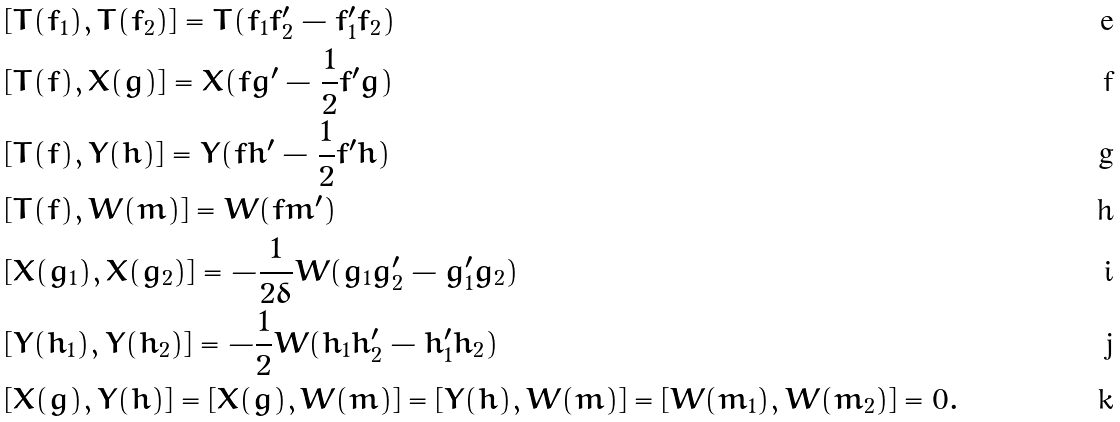<formula> <loc_0><loc_0><loc_500><loc_500>& [ T ( f _ { 1 } ) , T ( f _ { 2 } ) ] = T ( f _ { 1 } f ^ { \prime } _ { 2 } - f ^ { \prime } _ { 1 } f _ { 2 } ) \\ & [ T ( f ) , X ( g ) ] = X ( f g ^ { \prime } - \frac { 1 } { 2 } f ^ { \prime } g ) \\ & [ T ( f ) , Y ( h ) ] = Y ( f h ^ { \prime } - \frac { 1 } { 2 } f ^ { \prime } h ) \\ & [ T ( f ) , W ( m ) ] = W ( f m ^ { \prime } ) \\ & [ X ( g _ { 1 } ) , X ( g _ { 2 } ) ] = - \frac { 1 } { 2 \delta } W ( g _ { 1 } g ^ { \prime } _ { 2 } - g ^ { \prime } _ { 1 } g _ { 2 } ) \\ & [ Y ( h _ { 1 } ) , Y ( h _ { 2 } ) ] = - \frac { 1 } { 2 } W ( h _ { 1 } h ^ { \prime } _ { 2 } - h ^ { \prime } _ { 1 } h _ { 2 } ) \\ & [ X ( g ) , Y ( h ) ] = [ X ( g ) , W ( m ) ] = [ Y ( h ) , W ( m ) ] = [ W ( m _ { 1 } ) , W ( m _ { 2 } ) ] = 0 .</formula> 